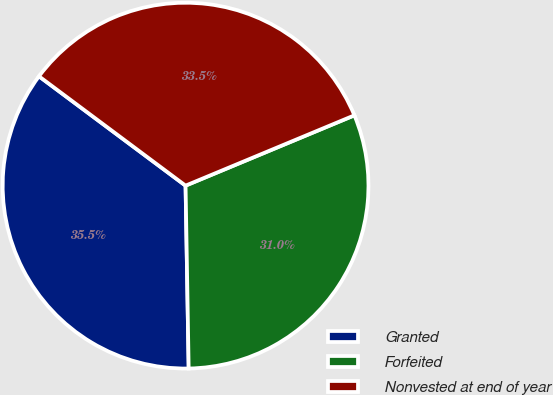<chart> <loc_0><loc_0><loc_500><loc_500><pie_chart><fcel>Granted<fcel>Forfeited<fcel>Nonvested at end of year<nl><fcel>35.47%<fcel>31.01%<fcel>33.52%<nl></chart> 